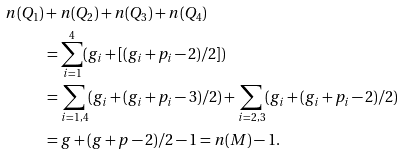Convert formula to latex. <formula><loc_0><loc_0><loc_500><loc_500>n ( Q _ { 1 } ) & + n ( Q _ { 2 } ) + n ( Q _ { 3 } ) + n ( Q _ { 4 } ) \\ & = \sum _ { i = 1 } ^ { 4 } ( g _ { i } + [ ( g _ { i } + p _ { i } - 2 ) / 2 ] ) \\ & = \sum _ { i = 1 , 4 } ( g _ { i } + ( g _ { i } + p _ { i } - 3 ) / 2 ) + \sum _ { i = 2 , 3 } ( g _ { i } + ( g _ { i } + p _ { i } - 2 ) / 2 ) \\ & = g + ( g + p - 2 ) / 2 - 1 = n ( M ) - 1 .</formula> 